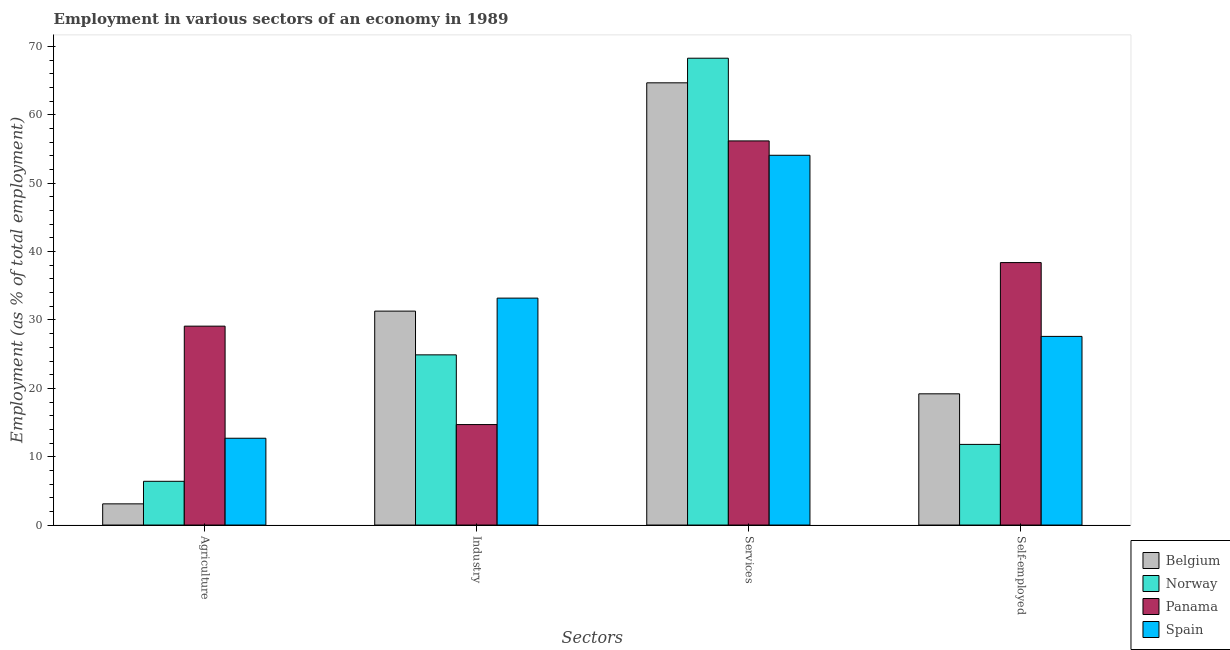How many different coloured bars are there?
Give a very brief answer. 4. How many bars are there on the 3rd tick from the left?
Offer a very short reply. 4. What is the label of the 3rd group of bars from the left?
Provide a short and direct response. Services. What is the percentage of workers in industry in Spain?
Give a very brief answer. 33.2. Across all countries, what is the maximum percentage of self employed workers?
Offer a terse response. 38.4. Across all countries, what is the minimum percentage of workers in services?
Provide a short and direct response. 54.1. In which country was the percentage of self employed workers maximum?
Offer a very short reply. Panama. What is the total percentage of workers in services in the graph?
Offer a very short reply. 243.3. What is the difference between the percentage of self employed workers in Norway and that in Spain?
Your answer should be compact. -15.8. What is the difference between the percentage of workers in industry in Belgium and the percentage of workers in services in Norway?
Give a very brief answer. -37. What is the average percentage of workers in services per country?
Your answer should be compact. 60.82. What is the difference between the percentage of workers in agriculture and percentage of self employed workers in Panama?
Your response must be concise. -9.3. In how many countries, is the percentage of workers in industry greater than 46 %?
Ensure brevity in your answer.  0. What is the ratio of the percentage of workers in agriculture in Belgium to that in Norway?
Provide a short and direct response. 0.48. What is the difference between the highest and the second highest percentage of self employed workers?
Your answer should be compact. 10.8. What is the difference between the highest and the lowest percentage of self employed workers?
Provide a succinct answer. 26.6. Is it the case that in every country, the sum of the percentage of self employed workers and percentage of workers in services is greater than the sum of percentage of workers in industry and percentage of workers in agriculture?
Keep it short and to the point. Yes. What does the 4th bar from the left in Agriculture represents?
Offer a terse response. Spain. What does the 3rd bar from the right in Industry represents?
Provide a succinct answer. Norway. Is it the case that in every country, the sum of the percentage of workers in agriculture and percentage of workers in industry is greater than the percentage of workers in services?
Ensure brevity in your answer.  No. Are all the bars in the graph horizontal?
Ensure brevity in your answer.  No. How many countries are there in the graph?
Your answer should be compact. 4. How many legend labels are there?
Give a very brief answer. 4. How are the legend labels stacked?
Provide a succinct answer. Vertical. What is the title of the graph?
Offer a terse response. Employment in various sectors of an economy in 1989. Does "Guinea-Bissau" appear as one of the legend labels in the graph?
Give a very brief answer. No. What is the label or title of the X-axis?
Make the answer very short. Sectors. What is the label or title of the Y-axis?
Ensure brevity in your answer.  Employment (as % of total employment). What is the Employment (as % of total employment) of Belgium in Agriculture?
Ensure brevity in your answer.  3.1. What is the Employment (as % of total employment) in Norway in Agriculture?
Your answer should be very brief. 6.4. What is the Employment (as % of total employment) in Panama in Agriculture?
Offer a very short reply. 29.1. What is the Employment (as % of total employment) of Spain in Agriculture?
Your answer should be compact. 12.7. What is the Employment (as % of total employment) of Belgium in Industry?
Offer a terse response. 31.3. What is the Employment (as % of total employment) of Norway in Industry?
Offer a very short reply. 24.9. What is the Employment (as % of total employment) of Panama in Industry?
Provide a short and direct response. 14.7. What is the Employment (as % of total employment) of Spain in Industry?
Make the answer very short. 33.2. What is the Employment (as % of total employment) in Belgium in Services?
Offer a very short reply. 64.7. What is the Employment (as % of total employment) of Norway in Services?
Your answer should be compact. 68.3. What is the Employment (as % of total employment) in Panama in Services?
Your response must be concise. 56.2. What is the Employment (as % of total employment) of Spain in Services?
Ensure brevity in your answer.  54.1. What is the Employment (as % of total employment) in Belgium in Self-employed?
Your answer should be compact. 19.2. What is the Employment (as % of total employment) in Norway in Self-employed?
Provide a short and direct response. 11.8. What is the Employment (as % of total employment) in Panama in Self-employed?
Keep it short and to the point. 38.4. What is the Employment (as % of total employment) of Spain in Self-employed?
Your response must be concise. 27.6. Across all Sectors, what is the maximum Employment (as % of total employment) in Belgium?
Offer a terse response. 64.7. Across all Sectors, what is the maximum Employment (as % of total employment) of Norway?
Your response must be concise. 68.3. Across all Sectors, what is the maximum Employment (as % of total employment) in Panama?
Give a very brief answer. 56.2. Across all Sectors, what is the maximum Employment (as % of total employment) of Spain?
Give a very brief answer. 54.1. Across all Sectors, what is the minimum Employment (as % of total employment) of Belgium?
Your answer should be very brief. 3.1. Across all Sectors, what is the minimum Employment (as % of total employment) in Norway?
Make the answer very short. 6.4. Across all Sectors, what is the minimum Employment (as % of total employment) of Panama?
Your response must be concise. 14.7. Across all Sectors, what is the minimum Employment (as % of total employment) in Spain?
Your response must be concise. 12.7. What is the total Employment (as % of total employment) in Belgium in the graph?
Ensure brevity in your answer.  118.3. What is the total Employment (as % of total employment) of Norway in the graph?
Make the answer very short. 111.4. What is the total Employment (as % of total employment) in Panama in the graph?
Give a very brief answer. 138.4. What is the total Employment (as % of total employment) of Spain in the graph?
Ensure brevity in your answer.  127.6. What is the difference between the Employment (as % of total employment) in Belgium in Agriculture and that in Industry?
Ensure brevity in your answer.  -28.2. What is the difference between the Employment (as % of total employment) in Norway in Agriculture and that in Industry?
Provide a succinct answer. -18.5. What is the difference between the Employment (as % of total employment) of Panama in Agriculture and that in Industry?
Keep it short and to the point. 14.4. What is the difference between the Employment (as % of total employment) of Spain in Agriculture and that in Industry?
Keep it short and to the point. -20.5. What is the difference between the Employment (as % of total employment) of Belgium in Agriculture and that in Services?
Your answer should be very brief. -61.6. What is the difference between the Employment (as % of total employment) in Norway in Agriculture and that in Services?
Give a very brief answer. -61.9. What is the difference between the Employment (as % of total employment) of Panama in Agriculture and that in Services?
Your answer should be compact. -27.1. What is the difference between the Employment (as % of total employment) of Spain in Agriculture and that in Services?
Your answer should be compact. -41.4. What is the difference between the Employment (as % of total employment) in Belgium in Agriculture and that in Self-employed?
Ensure brevity in your answer.  -16.1. What is the difference between the Employment (as % of total employment) of Spain in Agriculture and that in Self-employed?
Offer a terse response. -14.9. What is the difference between the Employment (as % of total employment) of Belgium in Industry and that in Services?
Make the answer very short. -33.4. What is the difference between the Employment (as % of total employment) of Norway in Industry and that in Services?
Make the answer very short. -43.4. What is the difference between the Employment (as % of total employment) of Panama in Industry and that in Services?
Offer a very short reply. -41.5. What is the difference between the Employment (as % of total employment) of Spain in Industry and that in Services?
Make the answer very short. -20.9. What is the difference between the Employment (as % of total employment) in Belgium in Industry and that in Self-employed?
Offer a terse response. 12.1. What is the difference between the Employment (as % of total employment) of Norway in Industry and that in Self-employed?
Give a very brief answer. 13.1. What is the difference between the Employment (as % of total employment) of Panama in Industry and that in Self-employed?
Make the answer very short. -23.7. What is the difference between the Employment (as % of total employment) in Belgium in Services and that in Self-employed?
Provide a succinct answer. 45.5. What is the difference between the Employment (as % of total employment) in Norway in Services and that in Self-employed?
Offer a very short reply. 56.5. What is the difference between the Employment (as % of total employment) in Belgium in Agriculture and the Employment (as % of total employment) in Norway in Industry?
Make the answer very short. -21.8. What is the difference between the Employment (as % of total employment) of Belgium in Agriculture and the Employment (as % of total employment) of Spain in Industry?
Provide a succinct answer. -30.1. What is the difference between the Employment (as % of total employment) in Norway in Agriculture and the Employment (as % of total employment) in Spain in Industry?
Offer a very short reply. -26.8. What is the difference between the Employment (as % of total employment) of Belgium in Agriculture and the Employment (as % of total employment) of Norway in Services?
Provide a succinct answer. -65.2. What is the difference between the Employment (as % of total employment) in Belgium in Agriculture and the Employment (as % of total employment) in Panama in Services?
Offer a terse response. -53.1. What is the difference between the Employment (as % of total employment) in Belgium in Agriculture and the Employment (as % of total employment) in Spain in Services?
Provide a succinct answer. -51. What is the difference between the Employment (as % of total employment) in Norway in Agriculture and the Employment (as % of total employment) in Panama in Services?
Your answer should be very brief. -49.8. What is the difference between the Employment (as % of total employment) of Norway in Agriculture and the Employment (as % of total employment) of Spain in Services?
Give a very brief answer. -47.7. What is the difference between the Employment (as % of total employment) in Belgium in Agriculture and the Employment (as % of total employment) in Panama in Self-employed?
Your response must be concise. -35.3. What is the difference between the Employment (as % of total employment) of Belgium in Agriculture and the Employment (as % of total employment) of Spain in Self-employed?
Your answer should be compact. -24.5. What is the difference between the Employment (as % of total employment) in Norway in Agriculture and the Employment (as % of total employment) in Panama in Self-employed?
Give a very brief answer. -32. What is the difference between the Employment (as % of total employment) of Norway in Agriculture and the Employment (as % of total employment) of Spain in Self-employed?
Offer a very short reply. -21.2. What is the difference between the Employment (as % of total employment) in Belgium in Industry and the Employment (as % of total employment) in Norway in Services?
Ensure brevity in your answer.  -37. What is the difference between the Employment (as % of total employment) in Belgium in Industry and the Employment (as % of total employment) in Panama in Services?
Your answer should be very brief. -24.9. What is the difference between the Employment (as % of total employment) in Belgium in Industry and the Employment (as % of total employment) in Spain in Services?
Provide a short and direct response. -22.8. What is the difference between the Employment (as % of total employment) in Norway in Industry and the Employment (as % of total employment) in Panama in Services?
Your response must be concise. -31.3. What is the difference between the Employment (as % of total employment) of Norway in Industry and the Employment (as % of total employment) of Spain in Services?
Your answer should be very brief. -29.2. What is the difference between the Employment (as % of total employment) of Panama in Industry and the Employment (as % of total employment) of Spain in Services?
Your response must be concise. -39.4. What is the difference between the Employment (as % of total employment) of Belgium in Industry and the Employment (as % of total employment) of Panama in Self-employed?
Your answer should be compact. -7.1. What is the difference between the Employment (as % of total employment) in Belgium in Industry and the Employment (as % of total employment) in Spain in Self-employed?
Make the answer very short. 3.7. What is the difference between the Employment (as % of total employment) in Norway in Industry and the Employment (as % of total employment) in Spain in Self-employed?
Your answer should be compact. -2.7. What is the difference between the Employment (as % of total employment) in Belgium in Services and the Employment (as % of total employment) in Norway in Self-employed?
Make the answer very short. 52.9. What is the difference between the Employment (as % of total employment) of Belgium in Services and the Employment (as % of total employment) of Panama in Self-employed?
Your response must be concise. 26.3. What is the difference between the Employment (as % of total employment) in Belgium in Services and the Employment (as % of total employment) in Spain in Self-employed?
Provide a short and direct response. 37.1. What is the difference between the Employment (as % of total employment) in Norway in Services and the Employment (as % of total employment) in Panama in Self-employed?
Offer a terse response. 29.9. What is the difference between the Employment (as % of total employment) in Norway in Services and the Employment (as % of total employment) in Spain in Self-employed?
Your answer should be compact. 40.7. What is the difference between the Employment (as % of total employment) in Panama in Services and the Employment (as % of total employment) in Spain in Self-employed?
Offer a terse response. 28.6. What is the average Employment (as % of total employment) of Belgium per Sectors?
Provide a short and direct response. 29.57. What is the average Employment (as % of total employment) of Norway per Sectors?
Offer a very short reply. 27.85. What is the average Employment (as % of total employment) in Panama per Sectors?
Ensure brevity in your answer.  34.6. What is the average Employment (as % of total employment) of Spain per Sectors?
Give a very brief answer. 31.9. What is the difference between the Employment (as % of total employment) in Norway and Employment (as % of total employment) in Panama in Agriculture?
Your answer should be compact. -22.7. What is the difference between the Employment (as % of total employment) of Panama and Employment (as % of total employment) of Spain in Agriculture?
Your response must be concise. 16.4. What is the difference between the Employment (as % of total employment) of Belgium and Employment (as % of total employment) of Norway in Industry?
Provide a succinct answer. 6.4. What is the difference between the Employment (as % of total employment) in Panama and Employment (as % of total employment) in Spain in Industry?
Your response must be concise. -18.5. What is the difference between the Employment (as % of total employment) of Norway and Employment (as % of total employment) of Spain in Services?
Your answer should be compact. 14.2. What is the difference between the Employment (as % of total employment) in Belgium and Employment (as % of total employment) in Panama in Self-employed?
Provide a short and direct response. -19.2. What is the difference between the Employment (as % of total employment) in Norway and Employment (as % of total employment) in Panama in Self-employed?
Offer a terse response. -26.6. What is the difference between the Employment (as % of total employment) in Norway and Employment (as % of total employment) in Spain in Self-employed?
Provide a succinct answer. -15.8. What is the ratio of the Employment (as % of total employment) of Belgium in Agriculture to that in Industry?
Your response must be concise. 0.1. What is the ratio of the Employment (as % of total employment) of Norway in Agriculture to that in Industry?
Provide a succinct answer. 0.26. What is the ratio of the Employment (as % of total employment) in Panama in Agriculture to that in Industry?
Give a very brief answer. 1.98. What is the ratio of the Employment (as % of total employment) of Spain in Agriculture to that in Industry?
Your response must be concise. 0.38. What is the ratio of the Employment (as % of total employment) of Belgium in Agriculture to that in Services?
Make the answer very short. 0.05. What is the ratio of the Employment (as % of total employment) in Norway in Agriculture to that in Services?
Provide a short and direct response. 0.09. What is the ratio of the Employment (as % of total employment) in Panama in Agriculture to that in Services?
Ensure brevity in your answer.  0.52. What is the ratio of the Employment (as % of total employment) in Spain in Agriculture to that in Services?
Your answer should be compact. 0.23. What is the ratio of the Employment (as % of total employment) in Belgium in Agriculture to that in Self-employed?
Offer a terse response. 0.16. What is the ratio of the Employment (as % of total employment) of Norway in Agriculture to that in Self-employed?
Your answer should be very brief. 0.54. What is the ratio of the Employment (as % of total employment) in Panama in Agriculture to that in Self-employed?
Provide a succinct answer. 0.76. What is the ratio of the Employment (as % of total employment) in Spain in Agriculture to that in Self-employed?
Provide a succinct answer. 0.46. What is the ratio of the Employment (as % of total employment) of Belgium in Industry to that in Services?
Your response must be concise. 0.48. What is the ratio of the Employment (as % of total employment) of Norway in Industry to that in Services?
Your answer should be very brief. 0.36. What is the ratio of the Employment (as % of total employment) in Panama in Industry to that in Services?
Make the answer very short. 0.26. What is the ratio of the Employment (as % of total employment) of Spain in Industry to that in Services?
Give a very brief answer. 0.61. What is the ratio of the Employment (as % of total employment) of Belgium in Industry to that in Self-employed?
Keep it short and to the point. 1.63. What is the ratio of the Employment (as % of total employment) in Norway in Industry to that in Self-employed?
Provide a succinct answer. 2.11. What is the ratio of the Employment (as % of total employment) in Panama in Industry to that in Self-employed?
Offer a terse response. 0.38. What is the ratio of the Employment (as % of total employment) in Spain in Industry to that in Self-employed?
Provide a succinct answer. 1.2. What is the ratio of the Employment (as % of total employment) of Belgium in Services to that in Self-employed?
Keep it short and to the point. 3.37. What is the ratio of the Employment (as % of total employment) of Norway in Services to that in Self-employed?
Provide a succinct answer. 5.79. What is the ratio of the Employment (as % of total employment) in Panama in Services to that in Self-employed?
Provide a short and direct response. 1.46. What is the ratio of the Employment (as % of total employment) in Spain in Services to that in Self-employed?
Ensure brevity in your answer.  1.96. What is the difference between the highest and the second highest Employment (as % of total employment) of Belgium?
Offer a terse response. 33.4. What is the difference between the highest and the second highest Employment (as % of total employment) in Norway?
Ensure brevity in your answer.  43.4. What is the difference between the highest and the second highest Employment (as % of total employment) of Spain?
Offer a terse response. 20.9. What is the difference between the highest and the lowest Employment (as % of total employment) in Belgium?
Provide a short and direct response. 61.6. What is the difference between the highest and the lowest Employment (as % of total employment) of Norway?
Keep it short and to the point. 61.9. What is the difference between the highest and the lowest Employment (as % of total employment) of Panama?
Offer a terse response. 41.5. What is the difference between the highest and the lowest Employment (as % of total employment) in Spain?
Give a very brief answer. 41.4. 